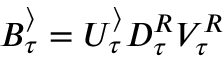<formula> <loc_0><loc_0><loc_500><loc_500>B _ { \tau } ^ { \rangle } = U _ { \tau } ^ { \rangle } D _ { \tau } ^ { R } V _ { \tau } ^ { R }</formula> 